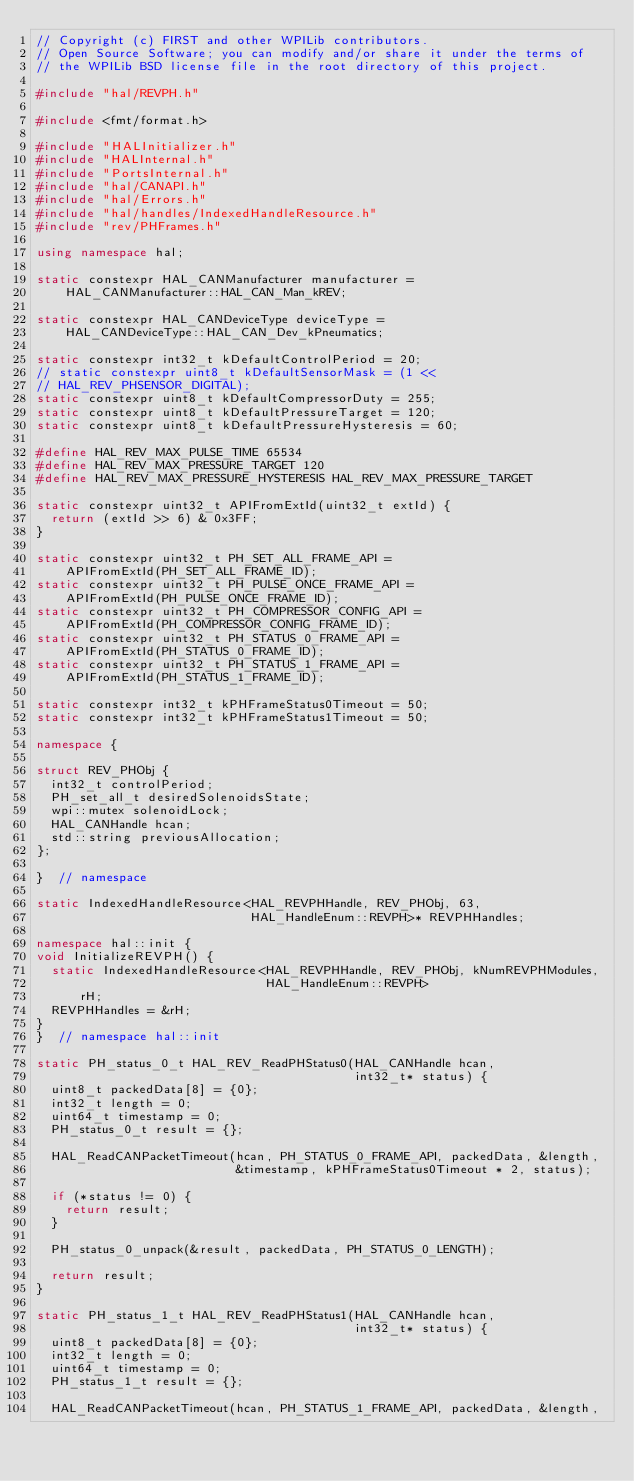Convert code to text. <code><loc_0><loc_0><loc_500><loc_500><_C++_>// Copyright (c) FIRST and other WPILib contributors.
// Open Source Software; you can modify and/or share it under the terms of
// the WPILib BSD license file in the root directory of this project.

#include "hal/REVPH.h"

#include <fmt/format.h>

#include "HALInitializer.h"
#include "HALInternal.h"
#include "PortsInternal.h"
#include "hal/CANAPI.h"
#include "hal/Errors.h"
#include "hal/handles/IndexedHandleResource.h"
#include "rev/PHFrames.h"

using namespace hal;

static constexpr HAL_CANManufacturer manufacturer =
    HAL_CANManufacturer::HAL_CAN_Man_kREV;

static constexpr HAL_CANDeviceType deviceType =
    HAL_CANDeviceType::HAL_CAN_Dev_kPneumatics;

static constexpr int32_t kDefaultControlPeriod = 20;
// static constexpr uint8_t kDefaultSensorMask = (1 <<
// HAL_REV_PHSENSOR_DIGITAL);
static constexpr uint8_t kDefaultCompressorDuty = 255;
static constexpr uint8_t kDefaultPressureTarget = 120;
static constexpr uint8_t kDefaultPressureHysteresis = 60;

#define HAL_REV_MAX_PULSE_TIME 65534
#define HAL_REV_MAX_PRESSURE_TARGET 120
#define HAL_REV_MAX_PRESSURE_HYSTERESIS HAL_REV_MAX_PRESSURE_TARGET

static constexpr uint32_t APIFromExtId(uint32_t extId) {
  return (extId >> 6) & 0x3FF;
}

static constexpr uint32_t PH_SET_ALL_FRAME_API =
    APIFromExtId(PH_SET_ALL_FRAME_ID);
static constexpr uint32_t PH_PULSE_ONCE_FRAME_API =
    APIFromExtId(PH_PULSE_ONCE_FRAME_ID);
static constexpr uint32_t PH_COMPRESSOR_CONFIG_API =
    APIFromExtId(PH_COMPRESSOR_CONFIG_FRAME_ID);
static constexpr uint32_t PH_STATUS_0_FRAME_API =
    APIFromExtId(PH_STATUS_0_FRAME_ID);
static constexpr uint32_t PH_STATUS_1_FRAME_API =
    APIFromExtId(PH_STATUS_1_FRAME_ID);

static constexpr int32_t kPHFrameStatus0Timeout = 50;
static constexpr int32_t kPHFrameStatus1Timeout = 50;

namespace {

struct REV_PHObj {
  int32_t controlPeriod;
  PH_set_all_t desiredSolenoidsState;
  wpi::mutex solenoidLock;
  HAL_CANHandle hcan;
  std::string previousAllocation;
};

}  // namespace

static IndexedHandleResource<HAL_REVPHHandle, REV_PHObj, 63,
                             HAL_HandleEnum::REVPH>* REVPHHandles;

namespace hal::init {
void InitializeREVPH() {
  static IndexedHandleResource<HAL_REVPHHandle, REV_PHObj, kNumREVPHModules,
                               HAL_HandleEnum::REVPH>
      rH;
  REVPHHandles = &rH;
}
}  // namespace hal::init

static PH_status_0_t HAL_REV_ReadPHStatus0(HAL_CANHandle hcan,
                                           int32_t* status) {
  uint8_t packedData[8] = {0};
  int32_t length = 0;
  uint64_t timestamp = 0;
  PH_status_0_t result = {};

  HAL_ReadCANPacketTimeout(hcan, PH_STATUS_0_FRAME_API, packedData, &length,
                           &timestamp, kPHFrameStatus0Timeout * 2, status);

  if (*status != 0) {
    return result;
  }

  PH_status_0_unpack(&result, packedData, PH_STATUS_0_LENGTH);

  return result;
}

static PH_status_1_t HAL_REV_ReadPHStatus1(HAL_CANHandle hcan,
                                           int32_t* status) {
  uint8_t packedData[8] = {0};
  int32_t length = 0;
  uint64_t timestamp = 0;
  PH_status_1_t result = {};

  HAL_ReadCANPacketTimeout(hcan, PH_STATUS_1_FRAME_API, packedData, &length,</code> 